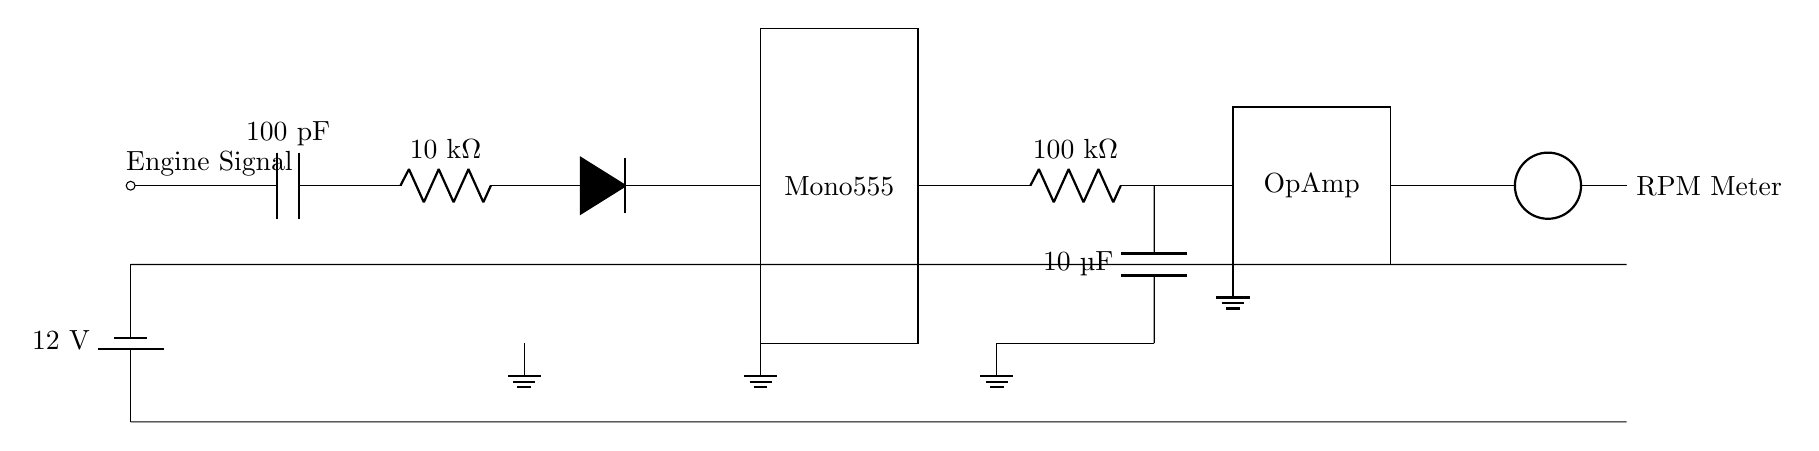What is the capacitance value in the signal conditioning section? The capacitance in the signal conditioning section is indicated next to the capacitor symbol and is labeled as 100 picofarads (pF).
Answer: 100 picofarads What component is used as the monostable multivibrator? The diagram labels the monostable multivibrator as a 555 timer, which is a common component used for this purpose in circuits.
Answer: 555 timer What type of device is used to convert the analog signal into a visual output? The output device is labeled as an RPM meter in the diagram, which displays the engine's revolutions per minute in an analog format.
Answer: RPM meter What is the power supply voltage in the circuit? The power supply is represented by a battery symbol which is labeled with a voltage of 12 volts, signifying the circuit's operating voltage.
Answer: 12 volts What is the resistance of the resistor connected after the capacitor in the integrator section? The resistance value in the integrator section is labeled as 100 kiloohms (kΩ) right next to the resistor symbol in the diagram, indicating the resistance value.
Answer: 100 kiloohms What role does the operational amplifier serve in this circuit? The operational amplifier is used in the circuit to amplify the voltage signal generated after the integration, making it possible to measure the RPM accurately.
Answer: Amplification How many grounds are present in the circuit? The circuit has four indicated ground connections, usually represented by the ground symbol next to various components.
Answer: Four 